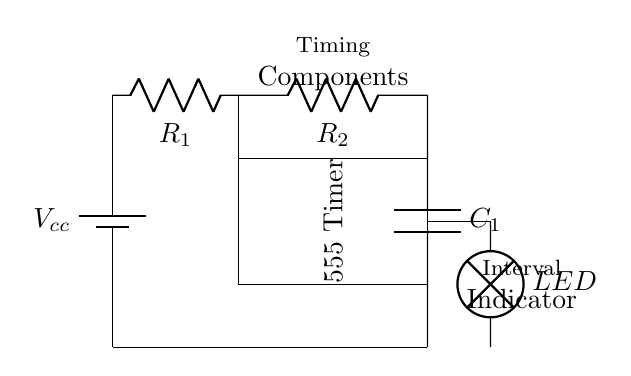What type of circuit is shown? This circuit is an astable multivibrator timer circuit, often used for generating pulse signals in timing applications, which is indicated by the presence of a 555 timer IC and a configuration supporting interval timing.
Answer: astable multivibrator What components are used in this circuit? The circuit includes a 555 timer IC, two resistors labeled R1 and R2, one capacitor labeled C1, and an LED as the output indicator.
Answer: 555 timer, R1, R2, C1, LED What is the purpose of the LED in this circuit? The LED indicates the output state of the timer circuit, providing a visual signal during the interval timing process, which allows users to see when a workout interval starts or ends.
Answer: interval indicator How many resistors are present in this circuit? There are two resistors, which are labeled R1 and R2, that contribute to setting the timing intervals in the circuit.
Answer: 2 What voltage is applied to the circuit? The circuit is powered by a DC voltage source, labeled Vcc, which is necessary for the operation of the components, particularly the 555 timer IC.
Answer: Vcc What role does the capacitor play in this circuit? The capacitor C1 is responsible for controlling the timing intervals by charging and discharging, which helps determine the frequency and duration of the output pulse generated by the 555 timer.
Answer: timing control What happens when the timing components are changed? Changing the values of R1, R2, or C1 will alter the frequency and duration of the output signal, effectively modifying the timing intervals for workouts, which impacts the workout management.
Answer: alters timing intervals 